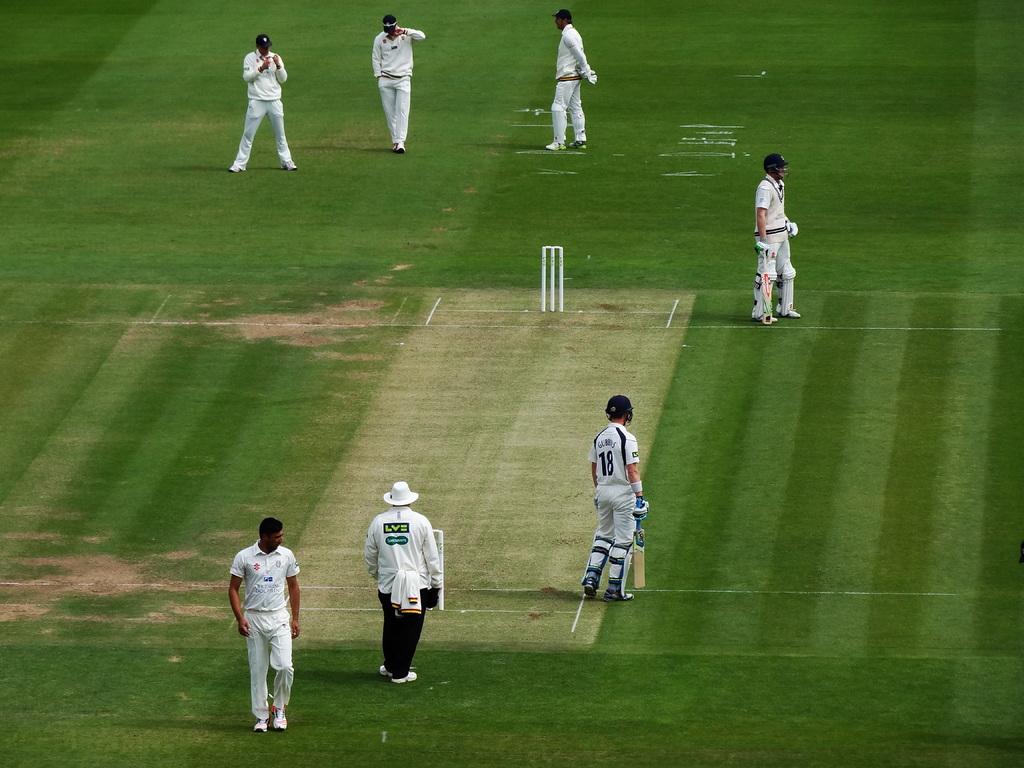What game is being played?
Your response must be concise. Answering does not require reading text in the image. 